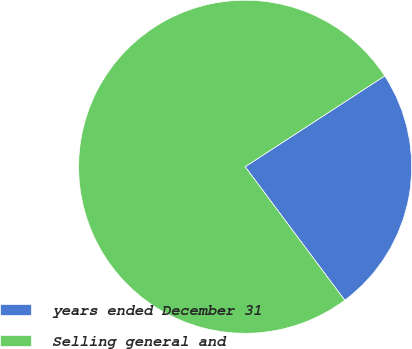Convert chart to OTSL. <chart><loc_0><loc_0><loc_500><loc_500><pie_chart><fcel>years ended December 31<fcel>Selling general and<nl><fcel>23.98%<fcel>76.02%<nl></chart> 